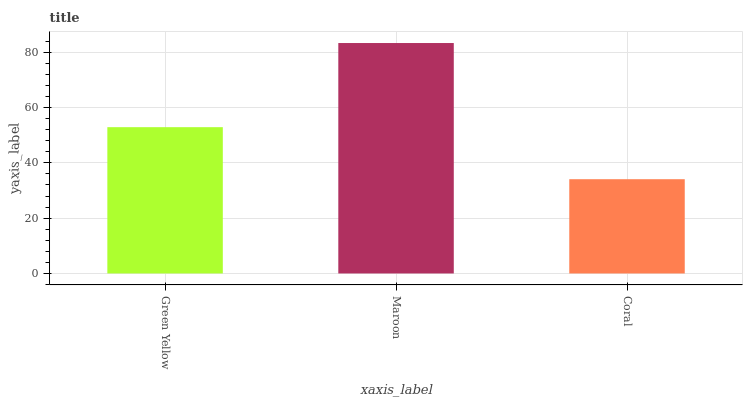Is Coral the minimum?
Answer yes or no. Yes. Is Maroon the maximum?
Answer yes or no. Yes. Is Maroon the minimum?
Answer yes or no. No. Is Coral the maximum?
Answer yes or no. No. Is Maroon greater than Coral?
Answer yes or no. Yes. Is Coral less than Maroon?
Answer yes or no. Yes. Is Coral greater than Maroon?
Answer yes or no. No. Is Maroon less than Coral?
Answer yes or no. No. Is Green Yellow the high median?
Answer yes or no. Yes. Is Green Yellow the low median?
Answer yes or no. Yes. Is Maroon the high median?
Answer yes or no. No. Is Coral the low median?
Answer yes or no. No. 